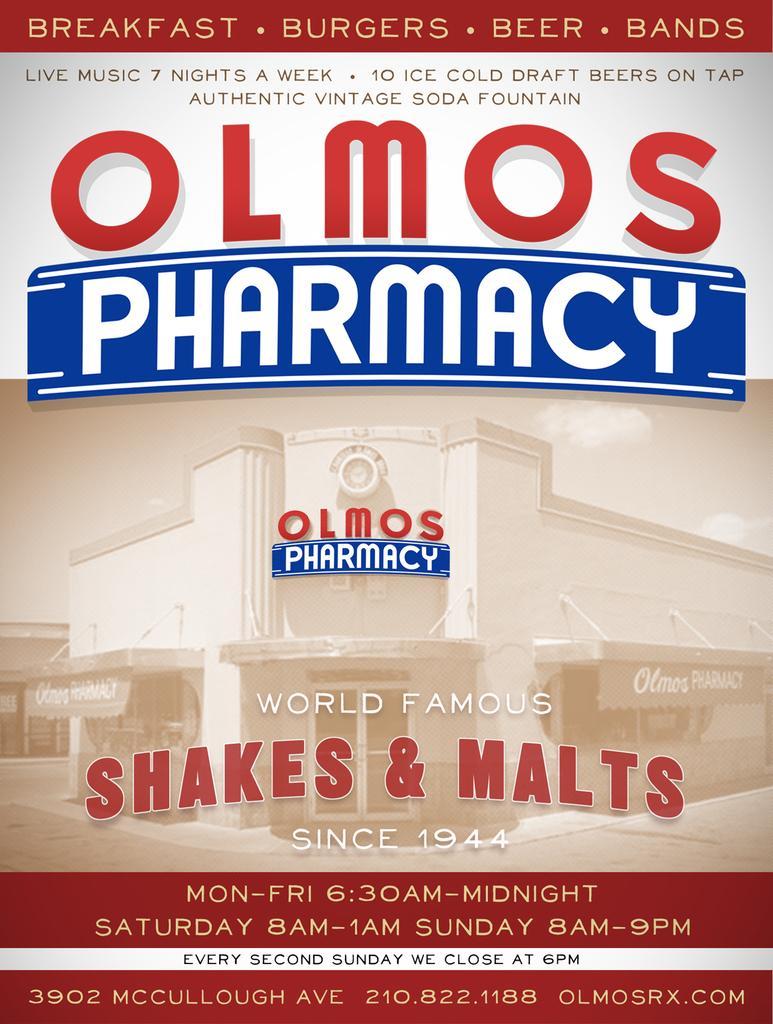Could you give a brief overview of what you see in this image? In this picture there is a poster and there is a picture of a building on the poster and there is text on the poster. 